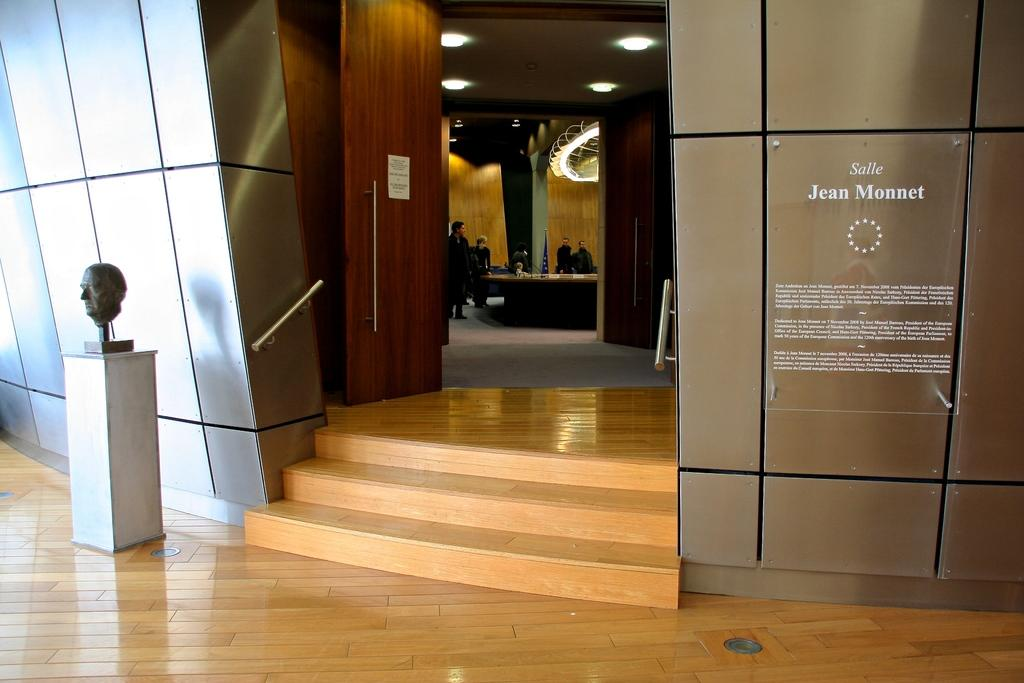How many people are in the image? There are people in the image, but the exact number is not specified. What architectural feature can be seen in the image? There are steps in the image. What is present on the left side of the image? There is a sculpture and a wooden door on the left side of the image. What type of lighting is present in the image? There are lights on the ceiling in the image. What type of oil can be seen dripping from the person's hand in the image? There is no person or oil present in the image. Can you describe the monkey's interaction with the sculpture in the image? There is no monkey present in the image, so it cannot interact with the sculpture. 